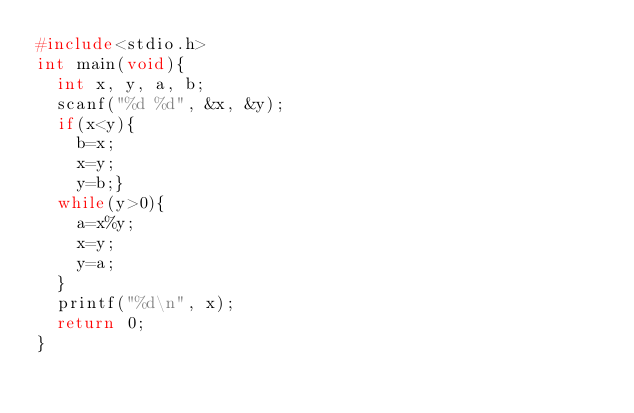Convert code to text. <code><loc_0><loc_0><loc_500><loc_500><_C_>#include<stdio.h>
int main(void){
	int x, y, a, b;
	scanf("%d %d", &x, &y);
	if(x<y){
		b=x;
		x=y;
		y=b;}
	while(y>0){
		a=x%y;
		x=y;
		y=a;
	}
	printf("%d\n", x);
	return 0;
}
</code> 